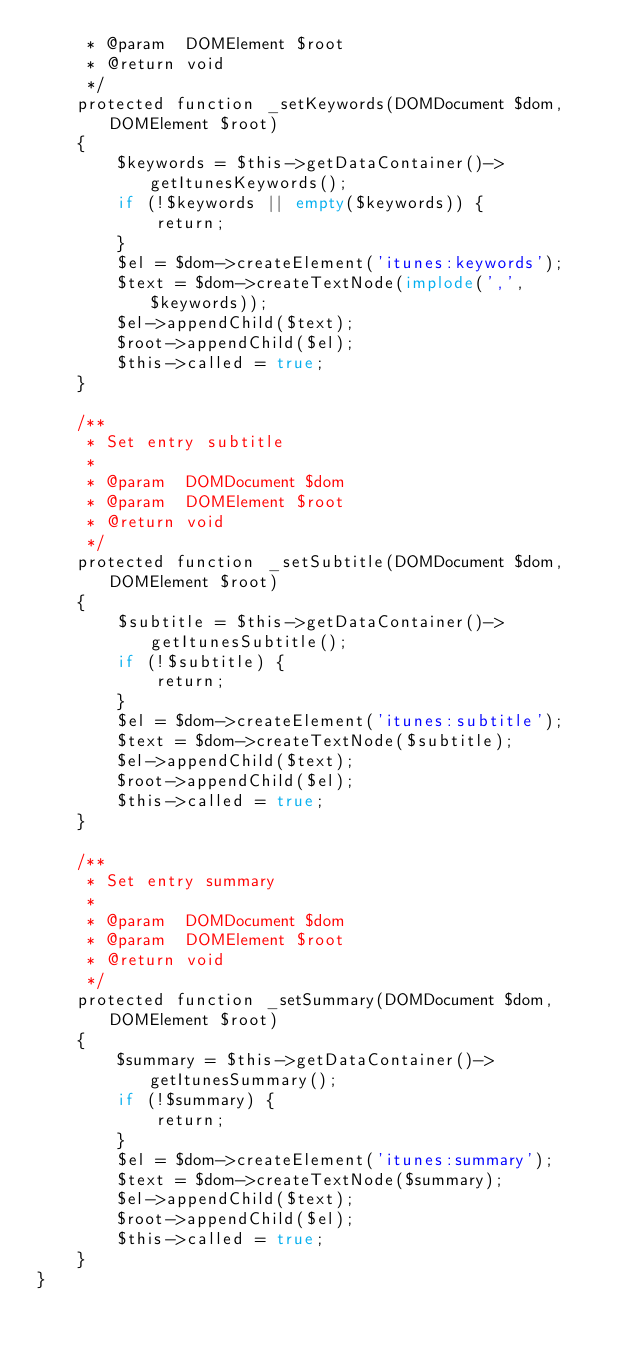Convert code to text. <code><loc_0><loc_0><loc_500><loc_500><_PHP_>     * @param  DOMElement $root
     * @return void
     */
    protected function _setKeywords(DOMDocument $dom, DOMElement $root)
    {
        $keywords = $this->getDataContainer()->getItunesKeywords();
        if (!$keywords || empty($keywords)) {
            return;
        }
        $el = $dom->createElement('itunes:keywords');
        $text = $dom->createTextNode(implode(',', $keywords));
        $el->appendChild($text);
        $root->appendChild($el);
        $this->called = true;
    }

    /**
     * Set entry subtitle
     *
     * @param  DOMDocument $dom
     * @param  DOMElement $root
     * @return void
     */
    protected function _setSubtitle(DOMDocument $dom, DOMElement $root)
    {
        $subtitle = $this->getDataContainer()->getItunesSubtitle();
        if (!$subtitle) {
            return;
        }
        $el = $dom->createElement('itunes:subtitle');
        $text = $dom->createTextNode($subtitle);
        $el->appendChild($text);
        $root->appendChild($el);
        $this->called = true;
    }

    /**
     * Set entry summary
     *
     * @param  DOMDocument $dom
     * @param  DOMElement $root
     * @return void
     */
    protected function _setSummary(DOMDocument $dom, DOMElement $root)
    {
        $summary = $this->getDataContainer()->getItunesSummary();
        if (!$summary) {
            return;
        }
        $el = $dom->createElement('itunes:summary');
        $text = $dom->createTextNode($summary);
        $el->appendChild($text);
        $root->appendChild($el);
        $this->called = true;
    }
}
</code> 